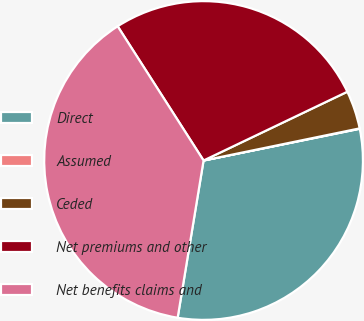Convert chart. <chart><loc_0><loc_0><loc_500><loc_500><pie_chart><fcel>Direct<fcel>Assumed<fcel>Ceded<fcel>Net premiums and other<fcel>Net benefits claims and<nl><fcel>30.79%<fcel>0.04%<fcel>3.87%<fcel>26.96%<fcel>38.34%<nl></chart> 